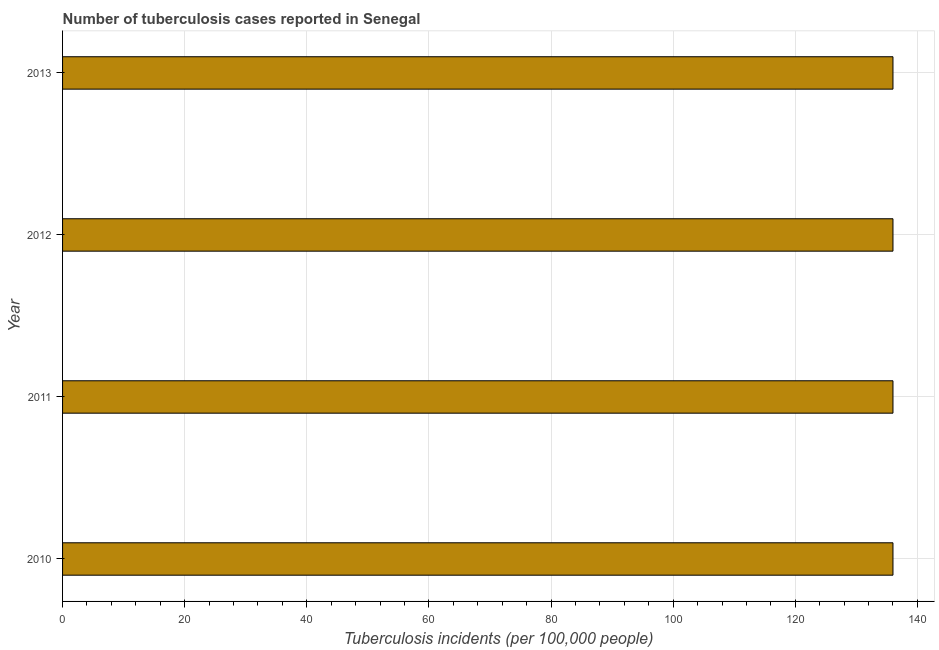Does the graph contain grids?
Ensure brevity in your answer.  Yes. What is the title of the graph?
Offer a terse response. Number of tuberculosis cases reported in Senegal. What is the label or title of the X-axis?
Offer a terse response. Tuberculosis incidents (per 100,0 people). What is the label or title of the Y-axis?
Give a very brief answer. Year. What is the number of tuberculosis incidents in 2011?
Ensure brevity in your answer.  136. Across all years, what is the maximum number of tuberculosis incidents?
Offer a terse response. 136. Across all years, what is the minimum number of tuberculosis incidents?
Make the answer very short. 136. In which year was the number of tuberculosis incidents minimum?
Offer a terse response. 2010. What is the sum of the number of tuberculosis incidents?
Keep it short and to the point. 544. What is the average number of tuberculosis incidents per year?
Make the answer very short. 136. What is the median number of tuberculosis incidents?
Your response must be concise. 136. Do a majority of the years between 2011 and 2012 (inclusive) have number of tuberculosis incidents greater than 120 ?
Ensure brevity in your answer.  Yes. Is the difference between the number of tuberculosis incidents in 2011 and 2012 greater than the difference between any two years?
Offer a very short reply. Yes. What is the difference between the highest and the second highest number of tuberculosis incidents?
Your answer should be very brief. 0. Is the sum of the number of tuberculosis incidents in 2012 and 2013 greater than the maximum number of tuberculosis incidents across all years?
Provide a short and direct response. Yes. What is the difference between the highest and the lowest number of tuberculosis incidents?
Your response must be concise. 0. In how many years, is the number of tuberculosis incidents greater than the average number of tuberculosis incidents taken over all years?
Provide a short and direct response. 0. How many bars are there?
Offer a very short reply. 4. Are all the bars in the graph horizontal?
Your answer should be very brief. Yes. What is the difference between two consecutive major ticks on the X-axis?
Your response must be concise. 20. Are the values on the major ticks of X-axis written in scientific E-notation?
Provide a succinct answer. No. What is the Tuberculosis incidents (per 100,000 people) in 2010?
Your answer should be very brief. 136. What is the Tuberculosis incidents (per 100,000 people) in 2011?
Offer a terse response. 136. What is the Tuberculosis incidents (per 100,000 people) of 2012?
Your answer should be compact. 136. What is the Tuberculosis incidents (per 100,000 people) in 2013?
Offer a very short reply. 136. What is the difference between the Tuberculosis incidents (per 100,000 people) in 2010 and 2011?
Provide a succinct answer. 0. What is the difference between the Tuberculosis incidents (per 100,000 people) in 2010 and 2012?
Your answer should be compact. 0. What is the difference between the Tuberculosis incidents (per 100,000 people) in 2010 and 2013?
Give a very brief answer. 0. What is the difference between the Tuberculosis incidents (per 100,000 people) in 2011 and 2012?
Offer a very short reply. 0. What is the ratio of the Tuberculosis incidents (per 100,000 people) in 2010 to that in 2011?
Your answer should be very brief. 1. What is the ratio of the Tuberculosis incidents (per 100,000 people) in 2010 to that in 2012?
Your answer should be compact. 1. What is the ratio of the Tuberculosis incidents (per 100,000 people) in 2011 to that in 2012?
Make the answer very short. 1. What is the ratio of the Tuberculosis incidents (per 100,000 people) in 2011 to that in 2013?
Your answer should be compact. 1. What is the ratio of the Tuberculosis incidents (per 100,000 people) in 2012 to that in 2013?
Provide a short and direct response. 1. 